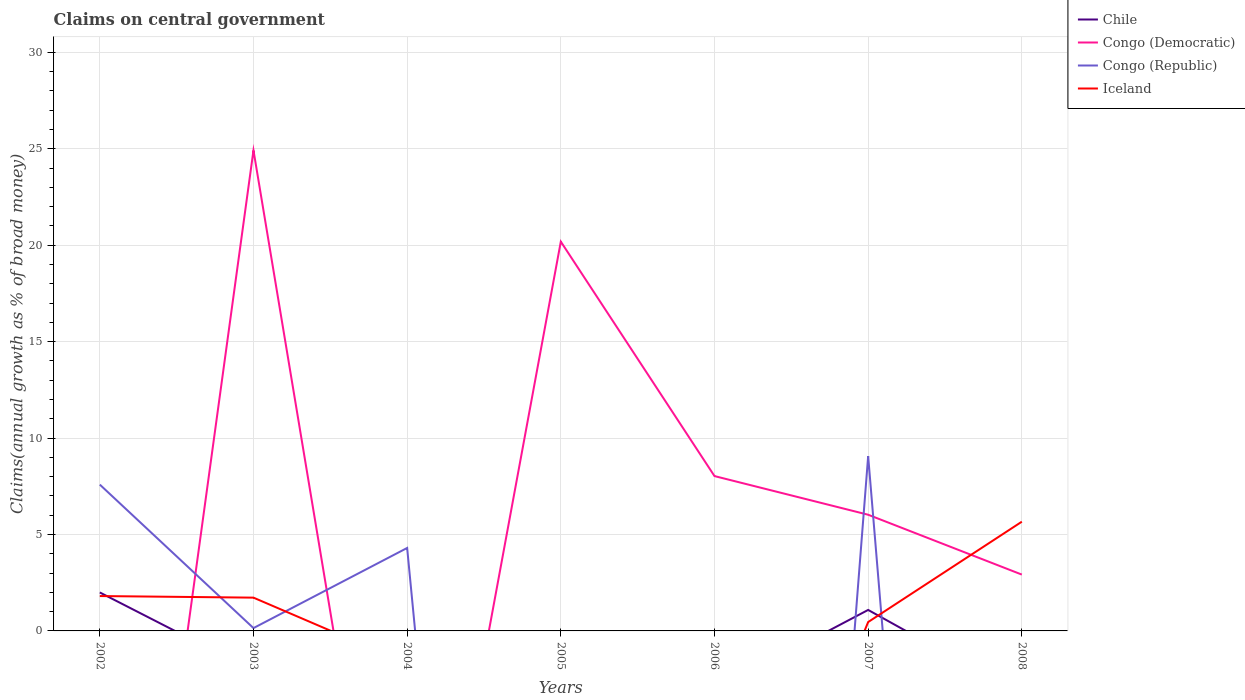What is the difference between the highest and the second highest percentage of broad money claimed on centeral government in Congo (Republic)?
Provide a short and direct response. 9.06. Is the percentage of broad money claimed on centeral government in Chile strictly greater than the percentage of broad money claimed on centeral government in Congo (Republic) over the years?
Provide a short and direct response. No. How many years are there in the graph?
Keep it short and to the point. 7. What is the difference between two consecutive major ticks on the Y-axis?
Keep it short and to the point. 5. Does the graph contain any zero values?
Ensure brevity in your answer.  Yes. Does the graph contain grids?
Offer a very short reply. Yes. What is the title of the graph?
Offer a terse response. Claims on central government. Does "Slovak Republic" appear as one of the legend labels in the graph?
Give a very brief answer. No. What is the label or title of the X-axis?
Provide a succinct answer. Years. What is the label or title of the Y-axis?
Make the answer very short. Claims(annual growth as % of broad money). What is the Claims(annual growth as % of broad money) of Chile in 2002?
Your answer should be very brief. 1.99. What is the Claims(annual growth as % of broad money) in Congo (Republic) in 2002?
Offer a terse response. 7.59. What is the Claims(annual growth as % of broad money) of Iceland in 2002?
Your response must be concise. 1.81. What is the Claims(annual growth as % of broad money) of Chile in 2003?
Ensure brevity in your answer.  0. What is the Claims(annual growth as % of broad money) of Congo (Democratic) in 2003?
Make the answer very short. 24.91. What is the Claims(annual growth as % of broad money) of Congo (Republic) in 2003?
Provide a succinct answer. 0.15. What is the Claims(annual growth as % of broad money) in Iceland in 2003?
Make the answer very short. 1.73. What is the Claims(annual growth as % of broad money) in Congo (Republic) in 2004?
Offer a terse response. 4.3. What is the Claims(annual growth as % of broad money) of Chile in 2005?
Ensure brevity in your answer.  0. What is the Claims(annual growth as % of broad money) in Congo (Democratic) in 2005?
Ensure brevity in your answer.  20.18. What is the Claims(annual growth as % of broad money) in Congo (Republic) in 2005?
Provide a succinct answer. 0. What is the Claims(annual growth as % of broad money) in Iceland in 2005?
Your answer should be very brief. 0. What is the Claims(annual growth as % of broad money) of Congo (Democratic) in 2006?
Offer a terse response. 8.03. What is the Claims(annual growth as % of broad money) in Chile in 2007?
Make the answer very short. 1.09. What is the Claims(annual growth as % of broad money) of Congo (Democratic) in 2007?
Your answer should be very brief. 6.02. What is the Claims(annual growth as % of broad money) of Congo (Republic) in 2007?
Provide a succinct answer. 9.06. What is the Claims(annual growth as % of broad money) in Iceland in 2007?
Give a very brief answer. 0.46. What is the Claims(annual growth as % of broad money) in Chile in 2008?
Keep it short and to the point. 0. What is the Claims(annual growth as % of broad money) in Congo (Democratic) in 2008?
Keep it short and to the point. 2.92. What is the Claims(annual growth as % of broad money) of Iceland in 2008?
Make the answer very short. 5.66. Across all years, what is the maximum Claims(annual growth as % of broad money) in Chile?
Offer a terse response. 1.99. Across all years, what is the maximum Claims(annual growth as % of broad money) in Congo (Democratic)?
Provide a succinct answer. 24.91. Across all years, what is the maximum Claims(annual growth as % of broad money) of Congo (Republic)?
Your response must be concise. 9.06. Across all years, what is the maximum Claims(annual growth as % of broad money) in Iceland?
Provide a succinct answer. 5.66. Across all years, what is the minimum Claims(annual growth as % of broad money) of Iceland?
Provide a succinct answer. 0. What is the total Claims(annual growth as % of broad money) in Chile in the graph?
Offer a very short reply. 3.08. What is the total Claims(annual growth as % of broad money) of Congo (Democratic) in the graph?
Your answer should be compact. 62.07. What is the total Claims(annual growth as % of broad money) in Congo (Republic) in the graph?
Ensure brevity in your answer.  21.1. What is the total Claims(annual growth as % of broad money) of Iceland in the graph?
Your answer should be very brief. 9.66. What is the difference between the Claims(annual growth as % of broad money) of Congo (Republic) in 2002 and that in 2003?
Provide a short and direct response. 7.44. What is the difference between the Claims(annual growth as % of broad money) in Iceland in 2002 and that in 2003?
Offer a terse response. 0.08. What is the difference between the Claims(annual growth as % of broad money) of Congo (Republic) in 2002 and that in 2004?
Your answer should be compact. 3.29. What is the difference between the Claims(annual growth as % of broad money) in Chile in 2002 and that in 2007?
Provide a succinct answer. 0.91. What is the difference between the Claims(annual growth as % of broad money) of Congo (Republic) in 2002 and that in 2007?
Provide a short and direct response. -1.48. What is the difference between the Claims(annual growth as % of broad money) of Iceland in 2002 and that in 2007?
Make the answer very short. 1.35. What is the difference between the Claims(annual growth as % of broad money) of Iceland in 2002 and that in 2008?
Provide a short and direct response. -3.85. What is the difference between the Claims(annual growth as % of broad money) in Congo (Republic) in 2003 and that in 2004?
Offer a terse response. -4.15. What is the difference between the Claims(annual growth as % of broad money) of Congo (Democratic) in 2003 and that in 2005?
Ensure brevity in your answer.  4.73. What is the difference between the Claims(annual growth as % of broad money) of Congo (Democratic) in 2003 and that in 2006?
Your response must be concise. 16.89. What is the difference between the Claims(annual growth as % of broad money) in Congo (Democratic) in 2003 and that in 2007?
Provide a short and direct response. 18.89. What is the difference between the Claims(annual growth as % of broad money) in Congo (Republic) in 2003 and that in 2007?
Offer a terse response. -8.92. What is the difference between the Claims(annual growth as % of broad money) of Iceland in 2003 and that in 2007?
Offer a terse response. 1.26. What is the difference between the Claims(annual growth as % of broad money) in Congo (Democratic) in 2003 and that in 2008?
Ensure brevity in your answer.  21.99. What is the difference between the Claims(annual growth as % of broad money) of Iceland in 2003 and that in 2008?
Provide a short and direct response. -3.94. What is the difference between the Claims(annual growth as % of broad money) in Congo (Republic) in 2004 and that in 2007?
Your answer should be very brief. -4.76. What is the difference between the Claims(annual growth as % of broad money) of Congo (Democratic) in 2005 and that in 2006?
Provide a succinct answer. 12.16. What is the difference between the Claims(annual growth as % of broad money) in Congo (Democratic) in 2005 and that in 2007?
Keep it short and to the point. 14.16. What is the difference between the Claims(annual growth as % of broad money) of Congo (Democratic) in 2005 and that in 2008?
Your answer should be compact. 17.26. What is the difference between the Claims(annual growth as % of broad money) of Congo (Democratic) in 2006 and that in 2007?
Make the answer very short. 2. What is the difference between the Claims(annual growth as % of broad money) of Congo (Democratic) in 2006 and that in 2008?
Give a very brief answer. 5.11. What is the difference between the Claims(annual growth as % of broad money) of Congo (Democratic) in 2007 and that in 2008?
Your answer should be very brief. 3.1. What is the difference between the Claims(annual growth as % of broad money) of Iceland in 2007 and that in 2008?
Ensure brevity in your answer.  -5.2. What is the difference between the Claims(annual growth as % of broad money) in Chile in 2002 and the Claims(annual growth as % of broad money) in Congo (Democratic) in 2003?
Offer a very short reply. -22.92. What is the difference between the Claims(annual growth as % of broad money) in Chile in 2002 and the Claims(annual growth as % of broad money) in Congo (Republic) in 2003?
Ensure brevity in your answer.  1.85. What is the difference between the Claims(annual growth as % of broad money) of Chile in 2002 and the Claims(annual growth as % of broad money) of Iceland in 2003?
Make the answer very short. 0.27. What is the difference between the Claims(annual growth as % of broad money) of Congo (Republic) in 2002 and the Claims(annual growth as % of broad money) of Iceland in 2003?
Offer a very short reply. 5.86. What is the difference between the Claims(annual growth as % of broad money) in Chile in 2002 and the Claims(annual growth as % of broad money) in Congo (Republic) in 2004?
Your answer should be compact. -2.31. What is the difference between the Claims(annual growth as % of broad money) of Chile in 2002 and the Claims(annual growth as % of broad money) of Congo (Democratic) in 2005?
Your response must be concise. -18.19. What is the difference between the Claims(annual growth as % of broad money) in Chile in 2002 and the Claims(annual growth as % of broad money) in Congo (Democratic) in 2006?
Make the answer very short. -6.03. What is the difference between the Claims(annual growth as % of broad money) in Chile in 2002 and the Claims(annual growth as % of broad money) in Congo (Democratic) in 2007?
Your answer should be compact. -4.03. What is the difference between the Claims(annual growth as % of broad money) of Chile in 2002 and the Claims(annual growth as % of broad money) of Congo (Republic) in 2007?
Give a very brief answer. -7.07. What is the difference between the Claims(annual growth as % of broad money) of Chile in 2002 and the Claims(annual growth as % of broad money) of Iceland in 2007?
Give a very brief answer. 1.53. What is the difference between the Claims(annual growth as % of broad money) in Congo (Republic) in 2002 and the Claims(annual growth as % of broad money) in Iceland in 2007?
Your response must be concise. 7.13. What is the difference between the Claims(annual growth as % of broad money) in Chile in 2002 and the Claims(annual growth as % of broad money) in Congo (Democratic) in 2008?
Ensure brevity in your answer.  -0.93. What is the difference between the Claims(annual growth as % of broad money) in Chile in 2002 and the Claims(annual growth as % of broad money) in Iceland in 2008?
Your answer should be compact. -3.67. What is the difference between the Claims(annual growth as % of broad money) of Congo (Republic) in 2002 and the Claims(annual growth as % of broad money) of Iceland in 2008?
Offer a terse response. 1.92. What is the difference between the Claims(annual growth as % of broad money) in Congo (Democratic) in 2003 and the Claims(annual growth as % of broad money) in Congo (Republic) in 2004?
Make the answer very short. 20.61. What is the difference between the Claims(annual growth as % of broad money) of Congo (Democratic) in 2003 and the Claims(annual growth as % of broad money) of Congo (Republic) in 2007?
Keep it short and to the point. 15.85. What is the difference between the Claims(annual growth as % of broad money) in Congo (Democratic) in 2003 and the Claims(annual growth as % of broad money) in Iceland in 2007?
Provide a succinct answer. 24.45. What is the difference between the Claims(annual growth as % of broad money) in Congo (Republic) in 2003 and the Claims(annual growth as % of broad money) in Iceland in 2007?
Offer a terse response. -0.31. What is the difference between the Claims(annual growth as % of broad money) of Congo (Democratic) in 2003 and the Claims(annual growth as % of broad money) of Iceland in 2008?
Your answer should be very brief. 19.25. What is the difference between the Claims(annual growth as % of broad money) of Congo (Republic) in 2003 and the Claims(annual growth as % of broad money) of Iceland in 2008?
Keep it short and to the point. -5.52. What is the difference between the Claims(annual growth as % of broad money) in Congo (Republic) in 2004 and the Claims(annual growth as % of broad money) in Iceland in 2007?
Your answer should be compact. 3.84. What is the difference between the Claims(annual growth as % of broad money) in Congo (Republic) in 2004 and the Claims(annual growth as % of broad money) in Iceland in 2008?
Provide a succinct answer. -1.36. What is the difference between the Claims(annual growth as % of broad money) in Congo (Democratic) in 2005 and the Claims(annual growth as % of broad money) in Congo (Republic) in 2007?
Offer a very short reply. 11.12. What is the difference between the Claims(annual growth as % of broad money) of Congo (Democratic) in 2005 and the Claims(annual growth as % of broad money) of Iceland in 2007?
Give a very brief answer. 19.72. What is the difference between the Claims(annual growth as % of broad money) of Congo (Democratic) in 2005 and the Claims(annual growth as % of broad money) of Iceland in 2008?
Your answer should be very brief. 14.52. What is the difference between the Claims(annual growth as % of broad money) in Congo (Democratic) in 2006 and the Claims(annual growth as % of broad money) in Congo (Republic) in 2007?
Ensure brevity in your answer.  -1.03. What is the difference between the Claims(annual growth as % of broad money) of Congo (Democratic) in 2006 and the Claims(annual growth as % of broad money) of Iceland in 2007?
Offer a terse response. 7.57. What is the difference between the Claims(annual growth as % of broad money) of Congo (Democratic) in 2006 and the Claims(annual growth as % of broad money) of Iceland in 2008?
Provide a short and direct response. 2.37. What is the difference between the Claims(annual growth as % of broad money) of Chile in 2007 and the Claims(annual growth as % of broad money) of Congo (Democratic) in 2008?
Your response must be concise. -1.83. What is the difference between the Claims(annual growth as % of broad money) of Chile in 2007 and the Claims(annual growth as % of broad money) of Iceland in 2008?
Keep it short and to the point. -4.58. What is the difference between the Claims(annual growth as % of broad money) of Congo (Democratic) in 2007 and the Claims(annual growth as % of broad money) of Iceland in 2008?
Your answer should be compact. 0.36. What is the difference between the Claims(annual growth as % of broad money) of Congo (Republic) in 2007 and the Claims(annual growth as % of broad money) of Iceland in 2008?
Your response must be concise. 3.4. What is the average Claims(annual growth as % of broad money) in Chile per year?
Provide a short and direct response. 0.44. What is the average Claims(annual growth as % of broad money) of Congo (Democratic) per year?
Offer a terse response. 8.87. What is the average Claims(annual growth as % of broad money) in Congo (Republic) per year?
Ensure brevity in your answer.  3.01. What is the average Claims(annual growth as % of broad money) in Iceland per year?
Ensure brevity in your answer.  1.38. In the year 2002, what is the difference between the Claims(annual growth as % of broad money) of Chile and Claims(annual growth as % of broad money) of Congo (Republic)?
Provide a succinct answer. -5.59. In the year 2002, what is the difference between the Claims(annual growth as % of broad money) of Chile and Claims(annual growth as % of broad money) of Iceland?
Offer a terse response. 0.19. In the year 2002, what is the difference between the Claims(annual growth as % of broad money) of Congo (Republic) and Claims(annual growth as % of broad money) of Iceland?
Offer a very short reply. 5.78. In the year 2003, what is the difference between the Claims(annual growth as % of broad money) in Congo (Democratic) and Claims(annual growth as % of broad money) in Congo (Republic)?
Your answer should be compact. 24.77. In the year 2003, what is the difference between the Claims(annual growth as % of broad money) of Congo (Democratic) and Claims(annual growth as % of broad money) of Iceland?
Provide a short and direct response. 23.19. In the year 2003, what is the difference between the Claims(annual growth as % of broad money) of Congo (Republic) and Claims(annual growth as % of broad money) of Iceland?
Offer a very short reply. -1.58. In the year 2007, what is the difference between the Claims(annual growth as % of broad money) in Chile and Claims(annual growth as % of broad money) in Congo (Democratic)?
Offer a terse response. -4.94. In the year 2007, what is the difference between the Claims(annual growth as % of broad money) of Chile and Claims(annual growth as % of broad money) of Congo (Republic)?
Provide a short and direct response. -7.97. In the year 2007, what is the difference between the Claims(annual growth as % of broad money) in Chile and Claims(annual growth as % of broad money) in Iceland?
Provide a succinct answer. 0.63. In the year 2007, what is the difference between the Claims(annual growth as % of broad money) in Congo (Democratic) and Claims(annual growth as % of broad money) in Congo (Republic)?
Your answer should be compact. -3.04. In the year 2007, what is the difference between the Claims(annual growth as % of broad money) of Congo (Democratic) and Claims(annual growth as % of broad money) of Iceland?
Your answer should be compact. 5.56. In the year 2007, what is the difference between the Claims(annual growth as % of broad money) of Congo (Republic) and Claims(annual growth as % of broad money) of Iceland?
Your response must be concise. 8.6. In the year 2008, what is the difference between the Claims(annual growth as % of broad money) of Congo (Democratic) and Claims(annual growth as % of broad money) of Iceland?
Keep it short and to the point. -2.74. What is the ratio of the Claims(annual growth as % of broad money) in Congo (Republic) in 2002 to that in 2003?
Make the answer very short. 51.71. What is the ratio of the Claims(annual growth as % of broad money) in Iceland in 2002 to that in 2003?
Provide a succinct answer. 1.05. What is the ratio of the Claims(annual growth as % of broad money) of Congo (Republic) in 2002 to that in 2004?
Give a very brief answer. 1.76. What is the ratio of the Claims(annual growth as % of broad money) in Chile in 2002 to that in 2007?
Offer a terse response. 1.83. What is the ratio of the Claims(annual growth as % of broad money) in Congo (Republic) in 2002 to that in 2007?
Keep it short and to the point. 0.84. What is the ratio of the Claims(annual growth as % of broad money) of Iceland in 2002 to that in 2007?
Your answer should be very brief. 3.93. What is the ratio of the Claims(annual growth as % of broad money) in Iceland in 2002 to that in 2008?
Offer a terse response. 0.32. What is the ratio of the Claims(annual growth as % of broad money) of Congo (Republic) in 2003 to that in 2004?
Keep it short and to the point. 0.03. What is the ratio of the Claims(annual growth as % of broad money) of Congo (Democratic) in 2003 to that in 2005?
Your answer should be very brief. 1.23. What is the ratio of the Claims(annual growth as % of broad money) of Congo (Democratic) in 2003 to that in 2006?
Your answer should be compact. 3.1. What is the ratio of the Claims(annual growth as % of broad money) in Congo (Democratic) in 2003 to that in 2007?
Ensure brevity in your answer.  4.14. What is the ratio of the Claims(annual growth as % of broad money) of Congo (Republic) in 2003 to that in 2007?
Make the answer very short. 0.02. What is the ratio of the Claims(annual growth as % of broad money) in Iceland in 2003 to that in 2007?
Provide a succinct answer. 3.75. What is the ratio of the Claims(annual growth as % of broad money) of Congo (Democratic) in 2003 to that in 2008?
Ensure brevity in your answer.  8.53. What is the ratio of the Claims(annual growth as % of broad money) of Iceland in 2003 to that in 2008?
Offer a terse response. 0.3. What is the ratio of the Claims(annual growth as % of broad money) of Congo (Republic) in 2004 to that in 2007?
Ensure brevity in your answer.  0.47. What is the ratio of the Claims(annual growth as % of broad money) of Congo (Democratic) in 2005 to that in 2006?
Give a very brief answer. 2.51. What is the ratio of the Claims(annual growth as % of broad money) of Congo (Democratic) in 2005 to that in 2007?
Offer a terse response. 3.35. What is the ratio of the Claims(annual growth as % of broad money) in Congo (Democratic) in 2005 to that in 2008?
Your answer should be compact. 6.91. What is the ratio of the Claims(annual growth as % of broad money) of Congo (Democratic) in 2006 to that in 2007?
Give a very brief answer. 1.33. What is the ratio of the Claims(annual growth as % of broad money) in Congo (Democratic) in 2006 to that in 2008?
Your answer should be very brief. 2.75. What is the ratio of the Claims(annual growth as % of broad money) of Congo (Democratic) in 2007 to that in 2008?
Provide a short and direct response. 2.06. What is the ratio of the Claims(annual growth as % of broad money) of Iceland in 2007 to that in 2008?
Provide a succinct answer. 0.08. What is the difference between the highest and the second highest Claims(annual growth as % of broad money) in Congo (Democratic)?
Provide a short and direct response. 4.73. What is the difference between the highest and the second highest Claims(annual growth as % of broad money) of Congo (Republic)?
Make the answer very short. 1.48. What is the difference between the highest and the second highest Claims(annual growth as % of broad money) of Iceland?
Your answer should be compact. 3.85. What is the difference between the highest and the lowest Claims(annual growth as % of broad money) in Chile?
Provide a short and direct response. 1.99. What is the difference between the highest and the lowest Claims(annual growth as % of broad money) in Congo (Democratic)?
Your answer should be compact. 24.91. What is the difference between the highest and the lowest Claims(annual growth as % of broad money) in Congo (Republic)?
Offer a very short reply. 9.06. What is the difference between the highest and the lowest Claims(annual growth as % of broad money) in Iceland?
Offer a terse response. 5.66. 